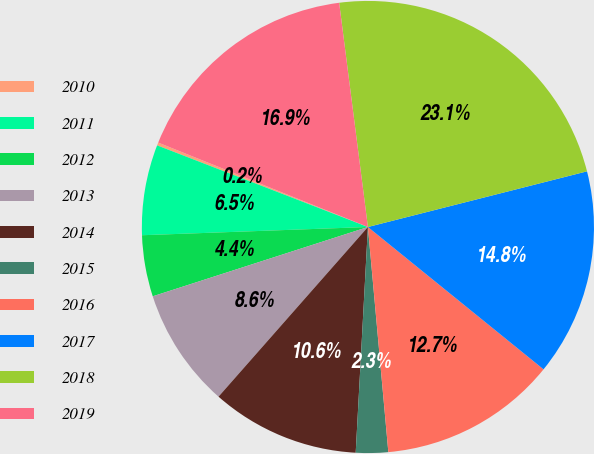Convert chart to OTSL. <chart><loc_0><loc_0><loc_500><loc_500><pie_chart><fcel>2010<fcel>2011<fcel>2012<fcel>2013<fcel>2014<fcel>2015<fcel>2016<fcel>2017<fcel>2018<fcel>2019<nl><fcel>0.21%<fcel>6.46%<fcel>4.38%<fcel>8.55%<fcel>10.63%<fcel>2.3%<fcel>12.72%<fcel>14.8%<fcel>23.07%<fcel>16.88%<nl></chart> 